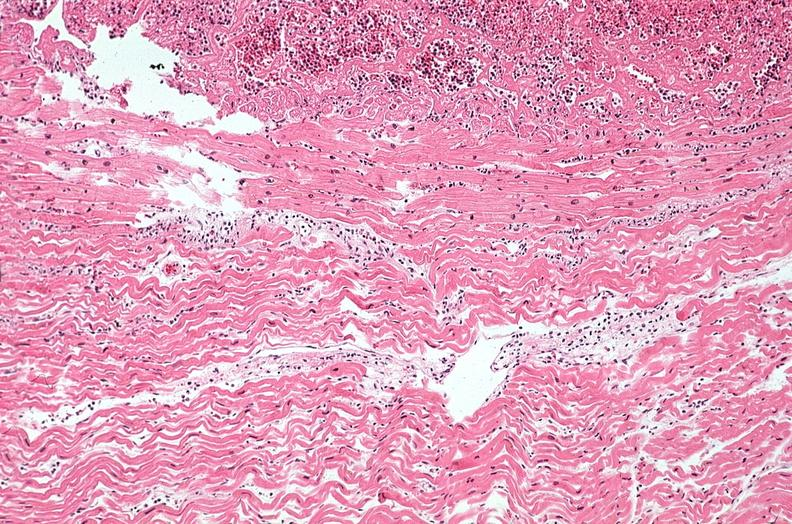s slide present?
Answer the question using a single word or phrase. No 